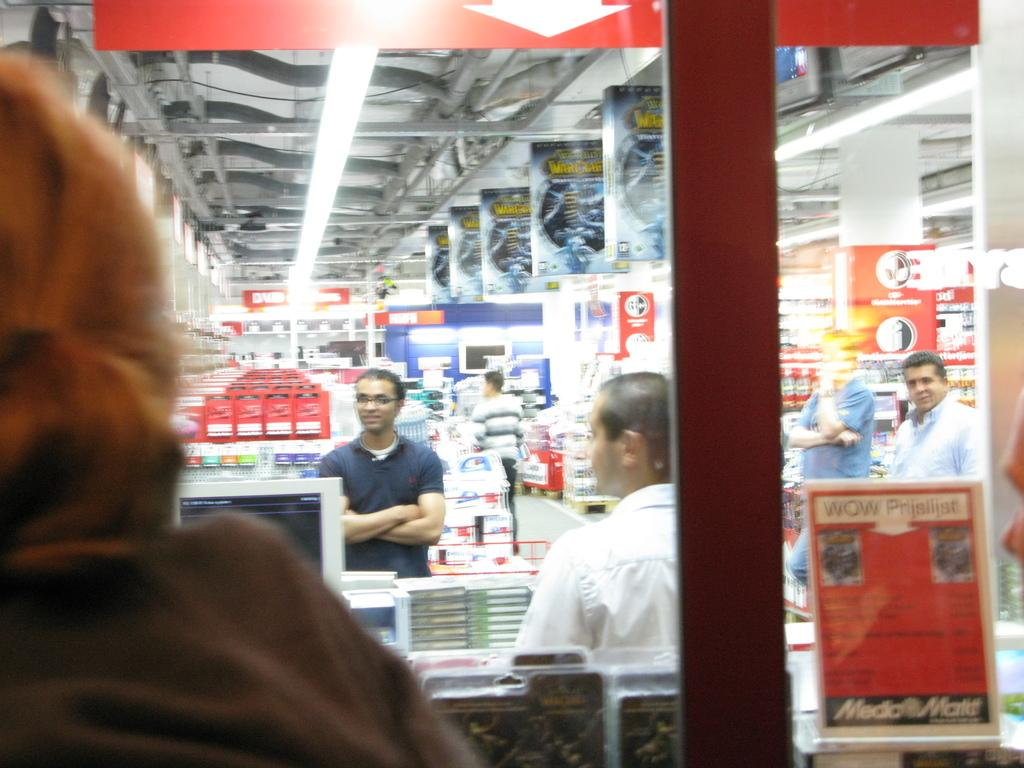What is the main subject of the picture? There is a person in the picture. What is on the glass surface in the image? There is a poster on a glass surface. What can be seen through the glass in the image? People, lights, rods, the floor, and objects can be seen through the glass. What type of volleyball is being played through the glass in the image? There is no volleyball present in the image, and therefore no such activity can be observed. 